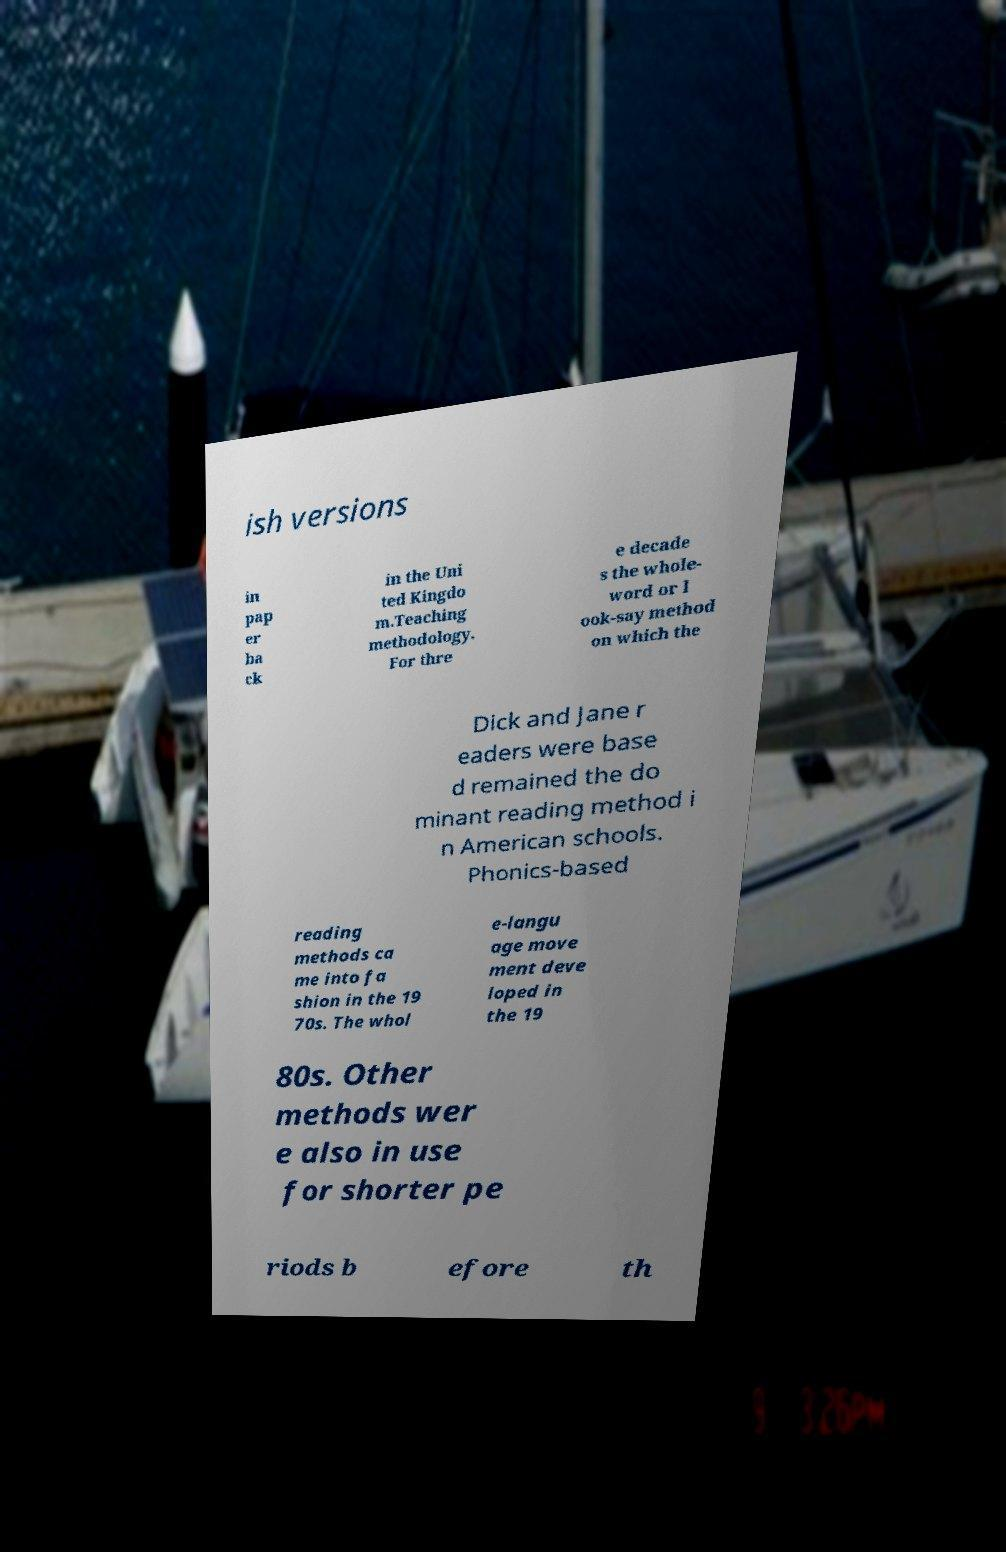What messages or text are displayed in this image? I need them in a readable, typed format. ish versions in pap er ba ck in the Uni ted Kingdo m.Teaching methodology. For thre e decade s the whole- word or l ook-say method on which the Dick and Jane r eaders were base d remained the do minant reading method i n American schools. Phonics-based reading methods ca me into fa shion in the 19 70s. The whol e-langu age move ment deve loped in the 19 80s. Other methods wer e also in use for shorter pe riods b efore th 